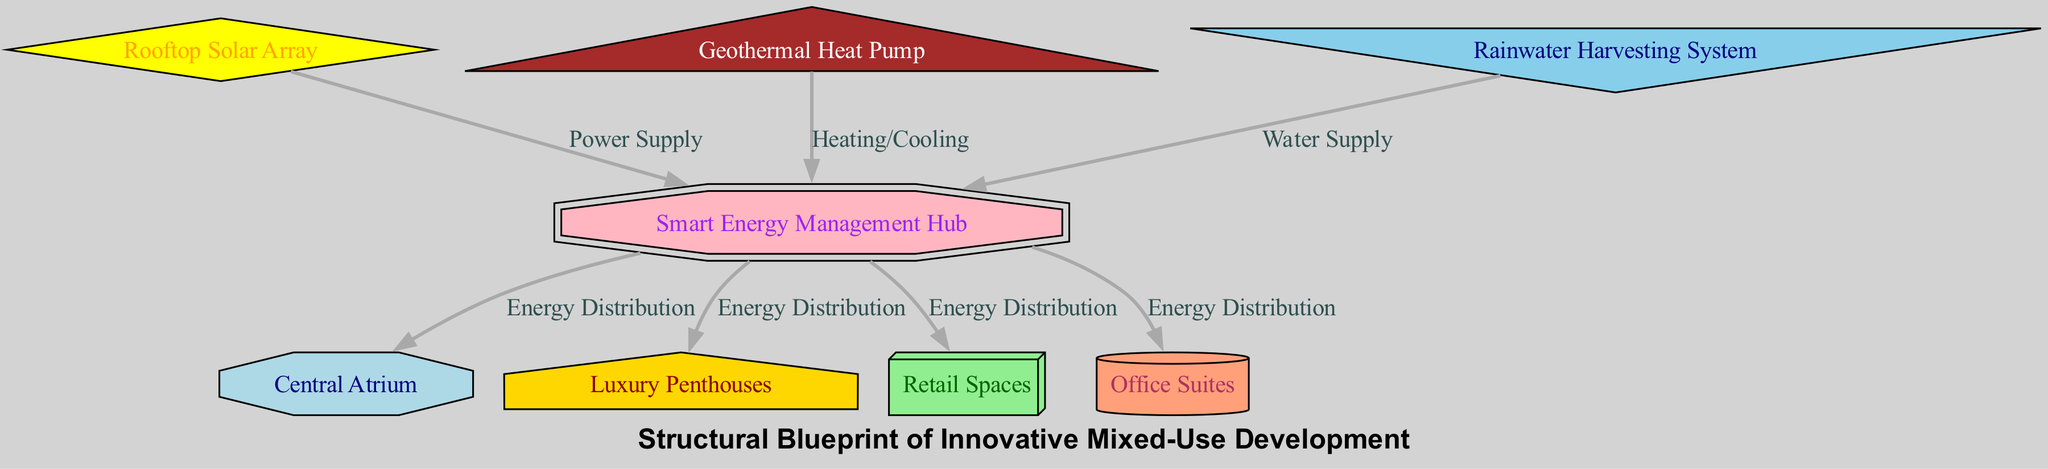What is the total number of nodes in the diagram? The diagram presents a collection of distinct components, known as nodes, each identified by a unique ID. By counting the nodes listed under the "nodes" key in the data, we find there are 8 nodes in total.
Answer: 8 Which node provides power supply to the Smart Energy Management Hub? Examining the edges, we see that the Rooftop Solar Array node connects to the Smart Energy Management Hub node with a label indicating "Power Supply." Therefore, the Rooftop Solar Array is the node providing power.
Answer: Rooftop Solar Array How many nodes receive energy distribution from the Smart Energy Management Hub? Looking at the edges connected to the Smart Energy Management Hub, it is linked to four nodes: Central Atrium, Luxury Penthouses, Retail Spaces, and Office Suites. Thus, we count 4 nodes receiving energy distribution.
Answer: 4 What is the function of the Rainwater Harvesting System in relation to the Smart Energy Management Hub? The Rainwater Harvesting System connects to the Smart Energy Management Hub with a label indicating "Water Supply." This implies that the Rainwater Harvesting System contributes water resources to the hub.
Answer: Water Supply Which node receives both heating/cooling and water supply? The edges show that both the Geothermal Heat Pump provides heating and cooling, and the Rainwater Harvesting System provides water supply to the Smart Energy Management Hub. Thus, the Smart Energy Management Hub receives both inputs.
Answer: Smart Energy Management Hub What shape represents the Luxury Penthouses in the diagram? In the provided information, the node styles mention that the Luxury Penthouses are represented in the shape designation as "house." Therefore, its graphical representation reflects this shape type.
Answer: house What connects to the Central Atrium from the Smart Energy Management Hub? From the edges, we identify that the Smart Energy Management Hub connects to the Central Atrium, labeled with "Energy Distribution." This shows the direct flow of energy from the hub to the atrium.
Answer: Energy Distribution Which system is responsible for the building's cooling mechanism? According to the connections, the Geothermal Heat Pump is linked to the Smart Energy Management Hub and is labeled as providing "Heating/Cooling." This confirms it as the crucial system for cooling in the building.
Answer: Geothermal Heat Pump 